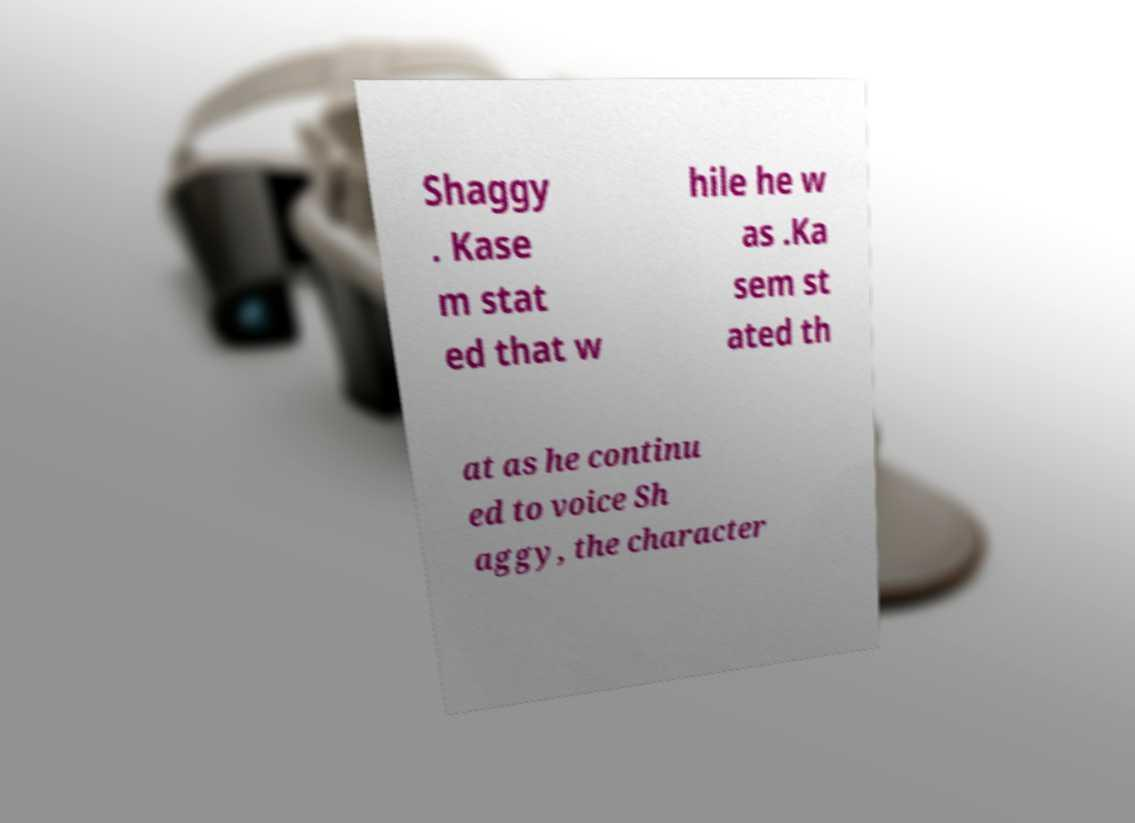Can you accurately transcribe the text from the provided image for me? Shaggy . Kase m stat ed that w hile he w as .Ka sem st ated th at as he continu ed to voice Sh aggy, the character 